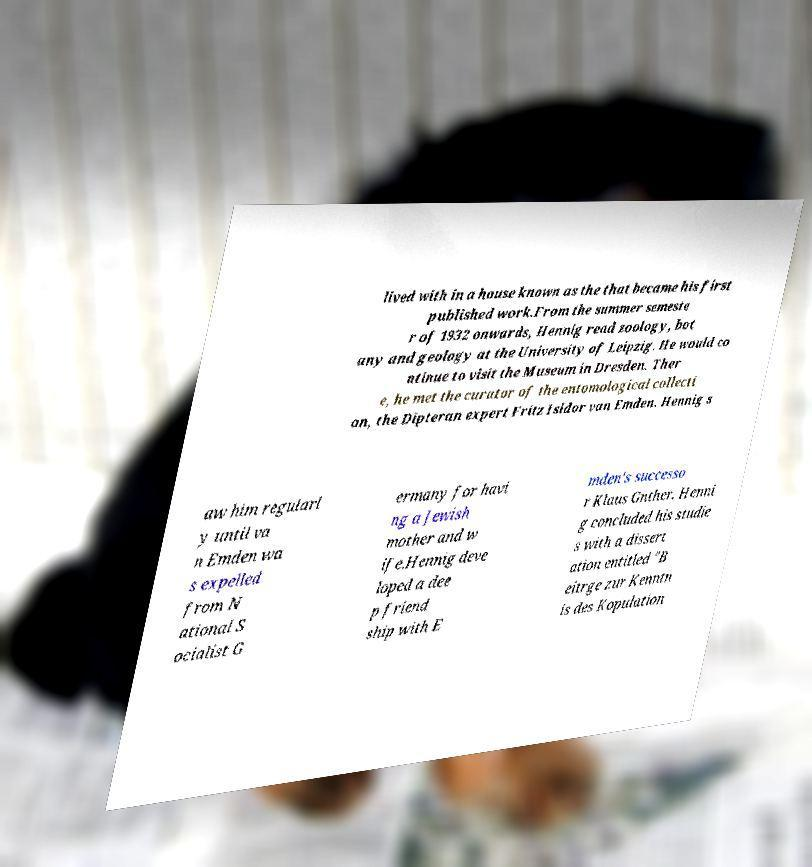I need the written content from this picture converted into text. Can you do that? lived with in a house known as the that became his first published work.From the summer semeste r of 1932 onwards, Hennig read zoology, bot any and geology at the University of Leipzig. He would co ntinue to visit the Museum in Dresden. Ther e, he met the curator of the entomological collecti on, the Dipteran expert Fritz Isidor van Emden. Hennig s aw him regularl y until va n Emden wa s expelled from N ational S ocialist G ermany for havi ng a Jewish mother and w ife.Hennig deve loped a dee p friend ship with E mden's successo r Klaus Gnther. Henni g concluded his studie s with a dissert ation entitled "B eitrge zur Kenntn is des Kopulation 